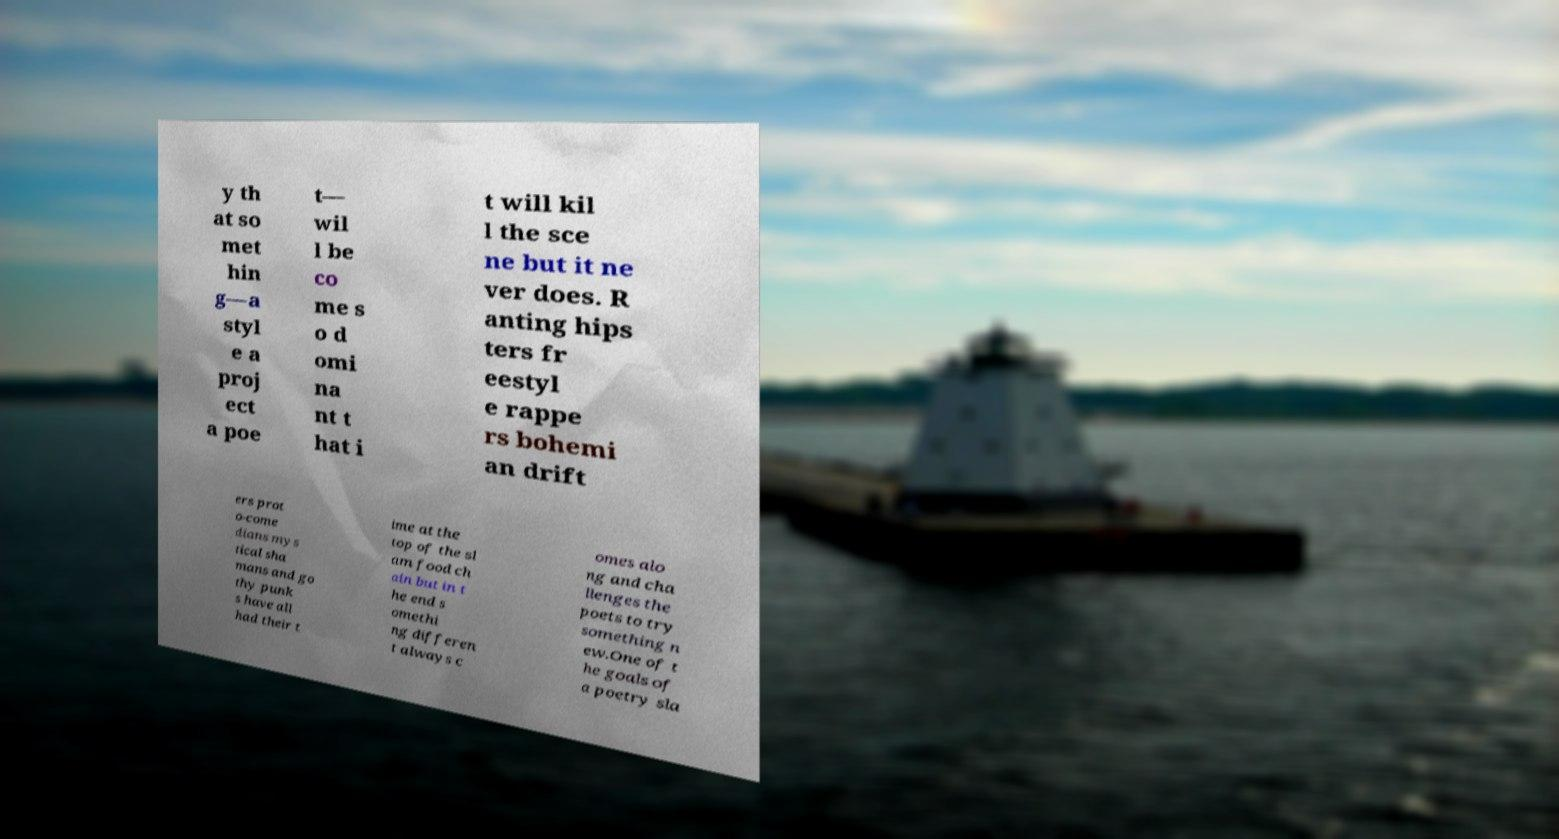Can you read and provide the text displayed in the image?This photo seems to have some interesting text. Can you extract and type it out for me? y th at so met hin g—a styl e a proj ect a poe t— wil l be co me s o d omi na nt t hat i t will kil l the sce ne but it ne ver does. R anting hips ters fr eestyl e rappe rs bohemi an drift ers prot o-come dians mys tical sha mans and go thy punk s have all had their t ime at the top of the sl am food ch ain but in t he end s omethi ng differen t always c omes alo ng and cha llenges the poets to try something n ew.One of t he goals of a poetry sla 